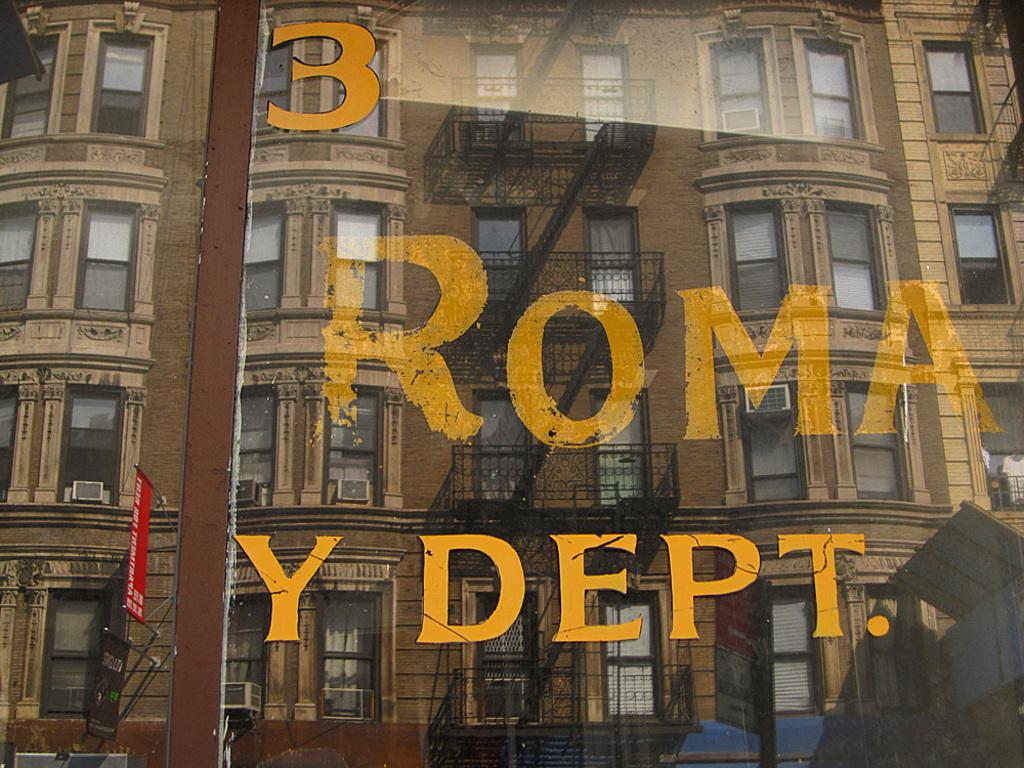What type of structure is present in the image? There is a building in the image. What feature of the building is mentioned in the facts? The building has windows. Can you describe any architectural elements in the image? There is a staircase in the image. What is written on a glass in the image? There is something written on a glass in the image. What can be seen on the left side of the image? There is a red board with poles on the left side of the image. What direction is the marble moving in the image? There is no marble present in the image. What story is being told by the people in the image? There are no people present in the image, so no story can be told. 